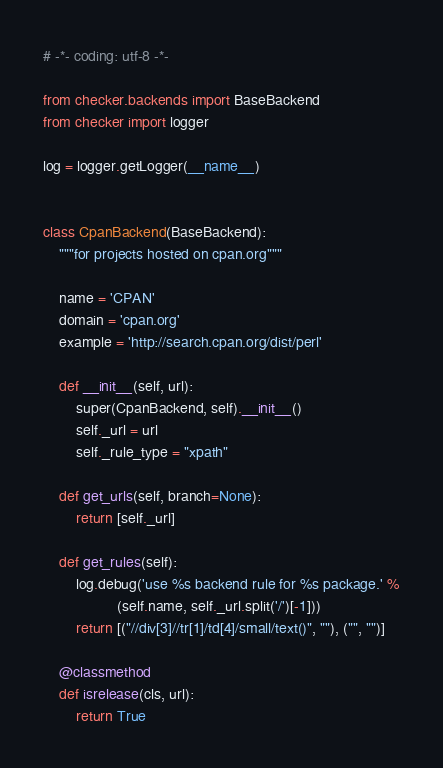Convert code to text. <code><loc_0><loc_0><loc_500><loc_500><_Python_># -*- coding: utf-8 -*-

from checker.backends import BaseBackend
from checker import logger

log = logger.getLogger(__name__)


class CpanBackend(BaseBackend):
    """for projects hosted on cpan.org"""

    name = 'CPAN'
    domain = 'cpan.org'
    example = 'http://search.cpan.org/dist/perl'

    def __init__(self, url):
        super(CpanBackend, self).__init__()
        self._url = url
        self._rule_type = "xpath"

    def get_urls(self, branch=None):
        return [self._url]

    def get_rules(self):
        log.debug('use %s backend rule for %s package.' %
                  (self.name, self._url.split('/')[-1]))
        return [("//div[3]//tr[1]/td[4]/small/text()", ""), ("", "")]

    @classmethod
    def isrelease(cls, url):
        return True
</code> 